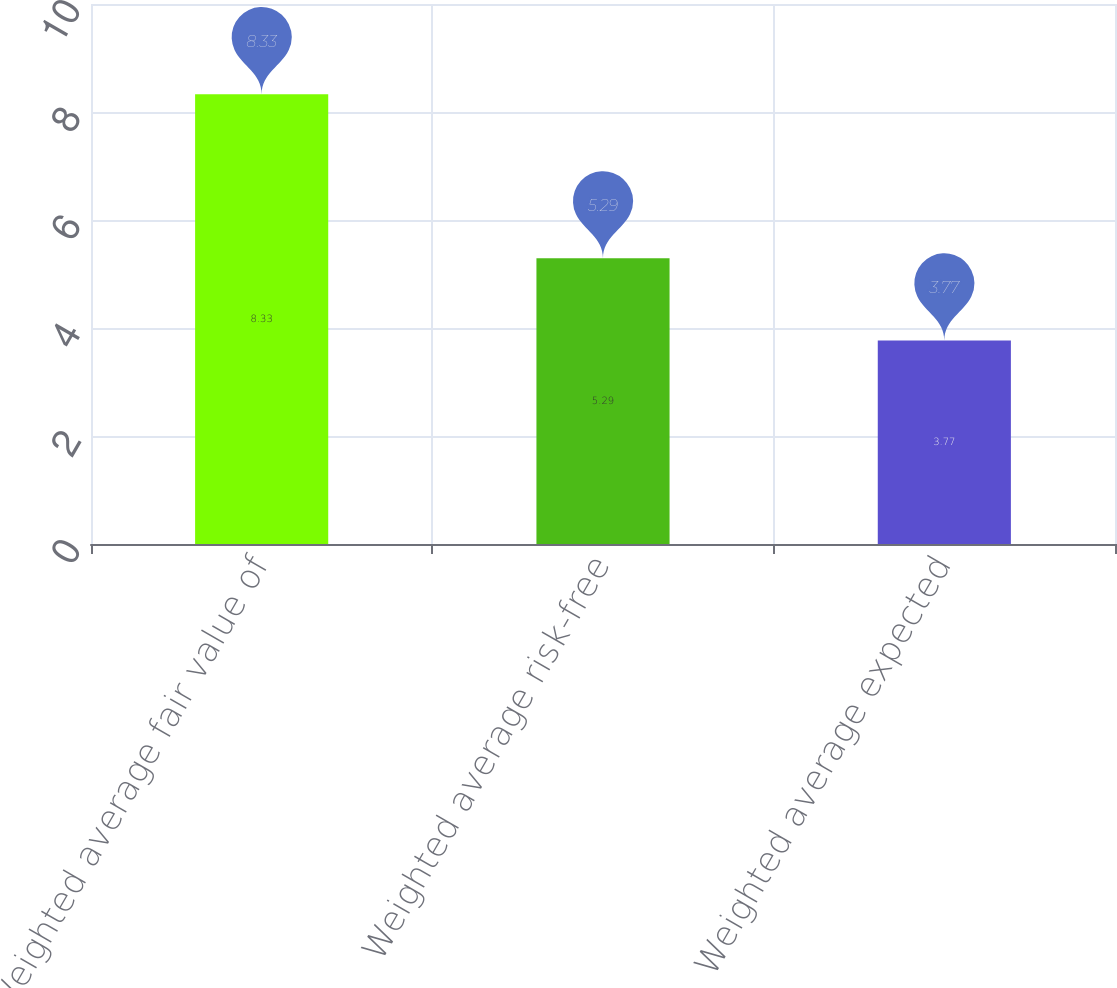Convert chart to OTSL. <chart><loc_0><loc_0><loc_500><loc_500><bar_chart><fcel>Weighted average fair value of<fcel>Weighted average risk-free<fcel>Weighted average expected<nl><fcel>8.33<fcel>5.29<fcel>3.77<nl></chart> 